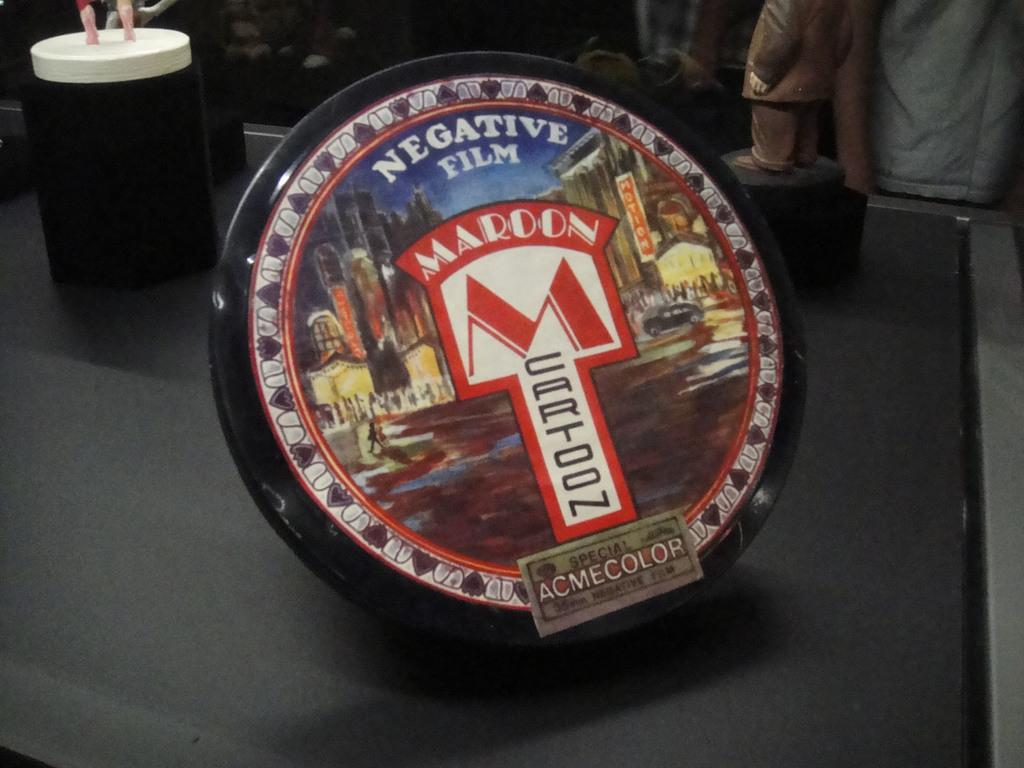What type of object can be seen in the image that is typically used for drinking? There is a glass in the image. What type of object can be seen in the image that represents a person or thing made of material, typically for decoration? There is a statue in the image. What type of object can be seen in the image that is used for holding or serving food or drinks? There is a tray in the image. Where are all of these objects located in the image? All of these objects are on a table. How would you describe the background of the image? The background of the image is blurry and dark. What flavor of hope can be seen in the image? There is no flavor of hope present in the image, as hope is an abstract concept and not something that can have a flavor. 